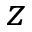<formula> <loc_0><loc_0><loc_500><loc_500>z</formula> 